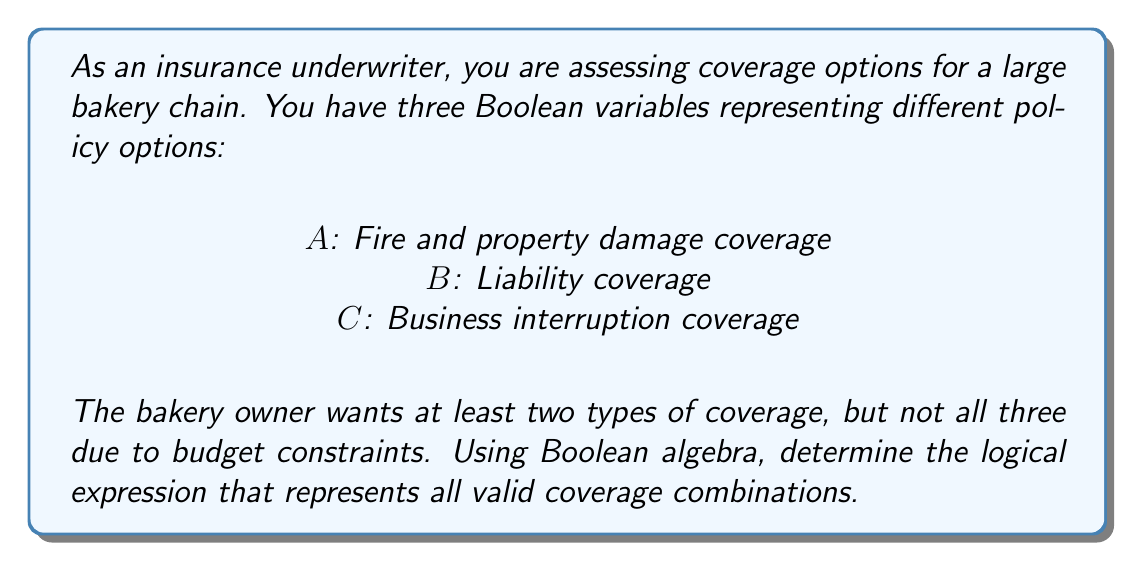Give your solution to this math problem. Let's approach this step-by-step using Boolean algebra:

1) We need to express "at least two types of coverage, but not all three". This can be broken down into three possible scenarios:

   a) A and B, but not C
   b) A and C, but not B
   c) B and C, but not A

2) We can represent these scenarios using Boolean expressions:

   a) $A \cdot B \cdot \overline{C}$
   b) $A \cdot \overline{B} \cdot C$
   c) $\overline{A} \cdot B \cdot C$

3) The final expression will be the logical OR of these three scenarios:

   $$(A \cdot B \cdot \overline{C}) + (A \cdot \overline{B} \cdot C) + (\overline{A} \cdot B \cdot C)$$

4) This expression can be simplified using Boolean algebra laws, but for the purpose of this problem, we'll keep it in this form as it clearly shows the three valid combinations.

5) In terms of set theory, this expression represents the union of the three possible combinations that satisfy the bakery owner's requirements.
Answer: $$(A \cdot B \cdot \overline{C}) + (A \cdot \overline{B} \cdot C) + (\overline{A} \cdot B \cdot C)$$ 